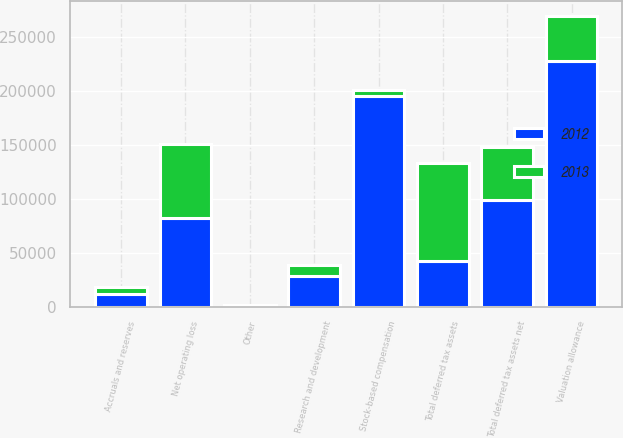Convert chart. <chart><loc_0><loc_0><loc_500><loc_500><stacked_bar_chart><ecel><fcel>Net operating loss<fcel>Accruals and reserves<fcel>Stock-based compensation<fcel>Research and development<fcel>Other<fcel>Total deferred tax assets<fcel>Valuation allowance<fcel>Total deferred tax assets net<nl><fcel>2012<fcel>82719<fcel>11435<fcel>195338<fcel>28572<fcel>1131<fcel>42175<fcel>227878<fcel>99480<nl><fcel>2013<fcel>68431<fcel>6698<fcel>5376<fcel>10052<fcel>610<fcel>91167<fcel>42175<fcel>48992<nl></chart> 